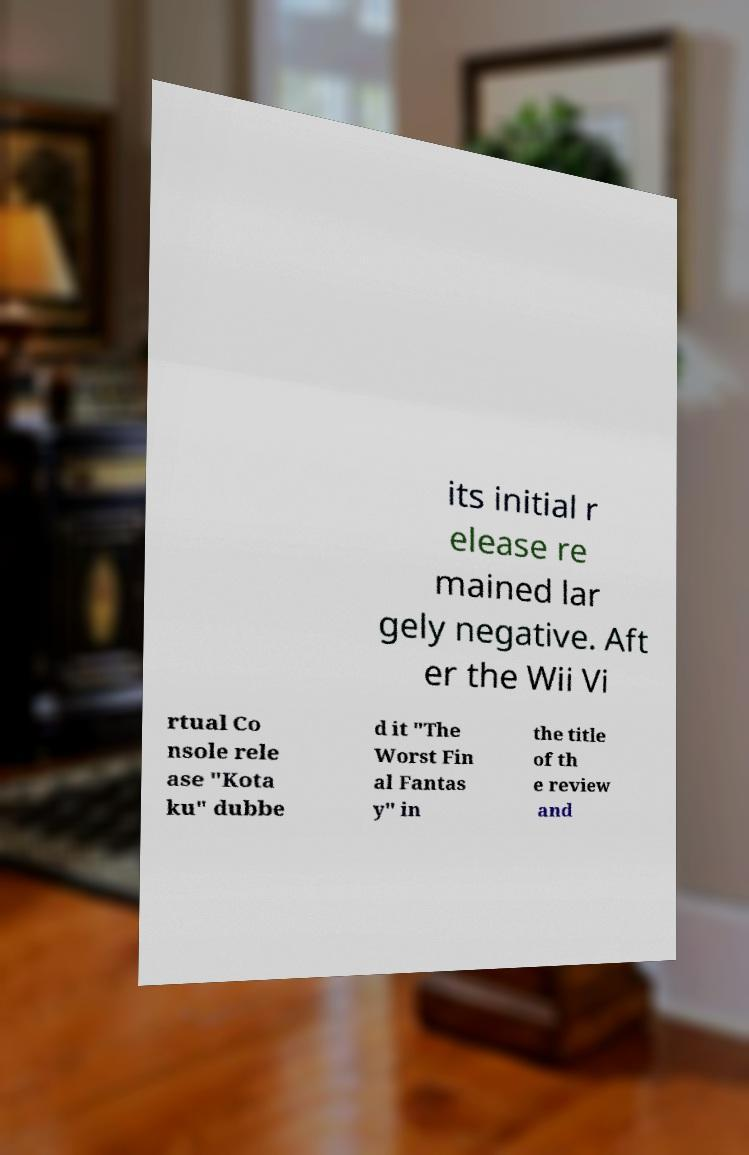Could you assist in decoding the text presented in this image and type it out clearly? its initial r elease re mained lar gely negative. Aft er the Wii Vi rtual Co nsole rele ase "Kota ku" dubbe d it "The Worst Fin al Fantas y" in the title of th e review and 